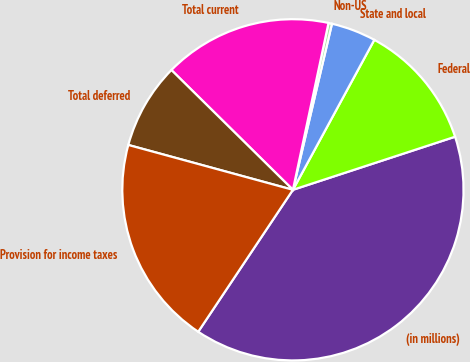Convert chart to OTSL. <chart><loc_0><loc_0><loc_500><loc_500><pie_chart><fcel>(in millions)<fcel>Federal<fcel>State and local<fcel>Non-US<fcel>Total current<fcel>Total deferred<fcel>Provision for income taxes<nl><fcel>39.4%<fcel>12.05%<fcel>4.24%<fcel>0.33%<fcel>15.96%<fcel>8.15%<fcel>19.87%<nl></chart> 